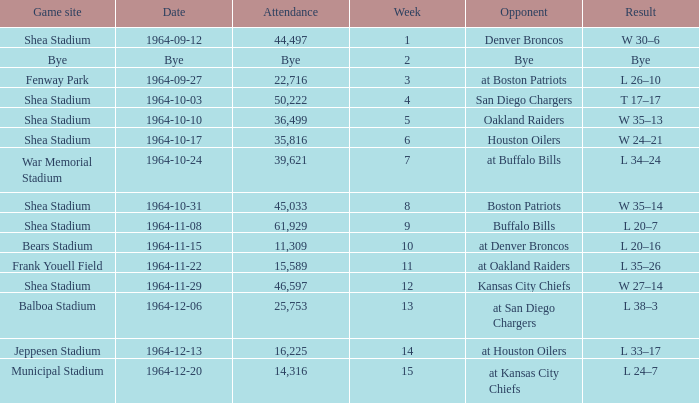What's the result of the game against Bye? Bye. 